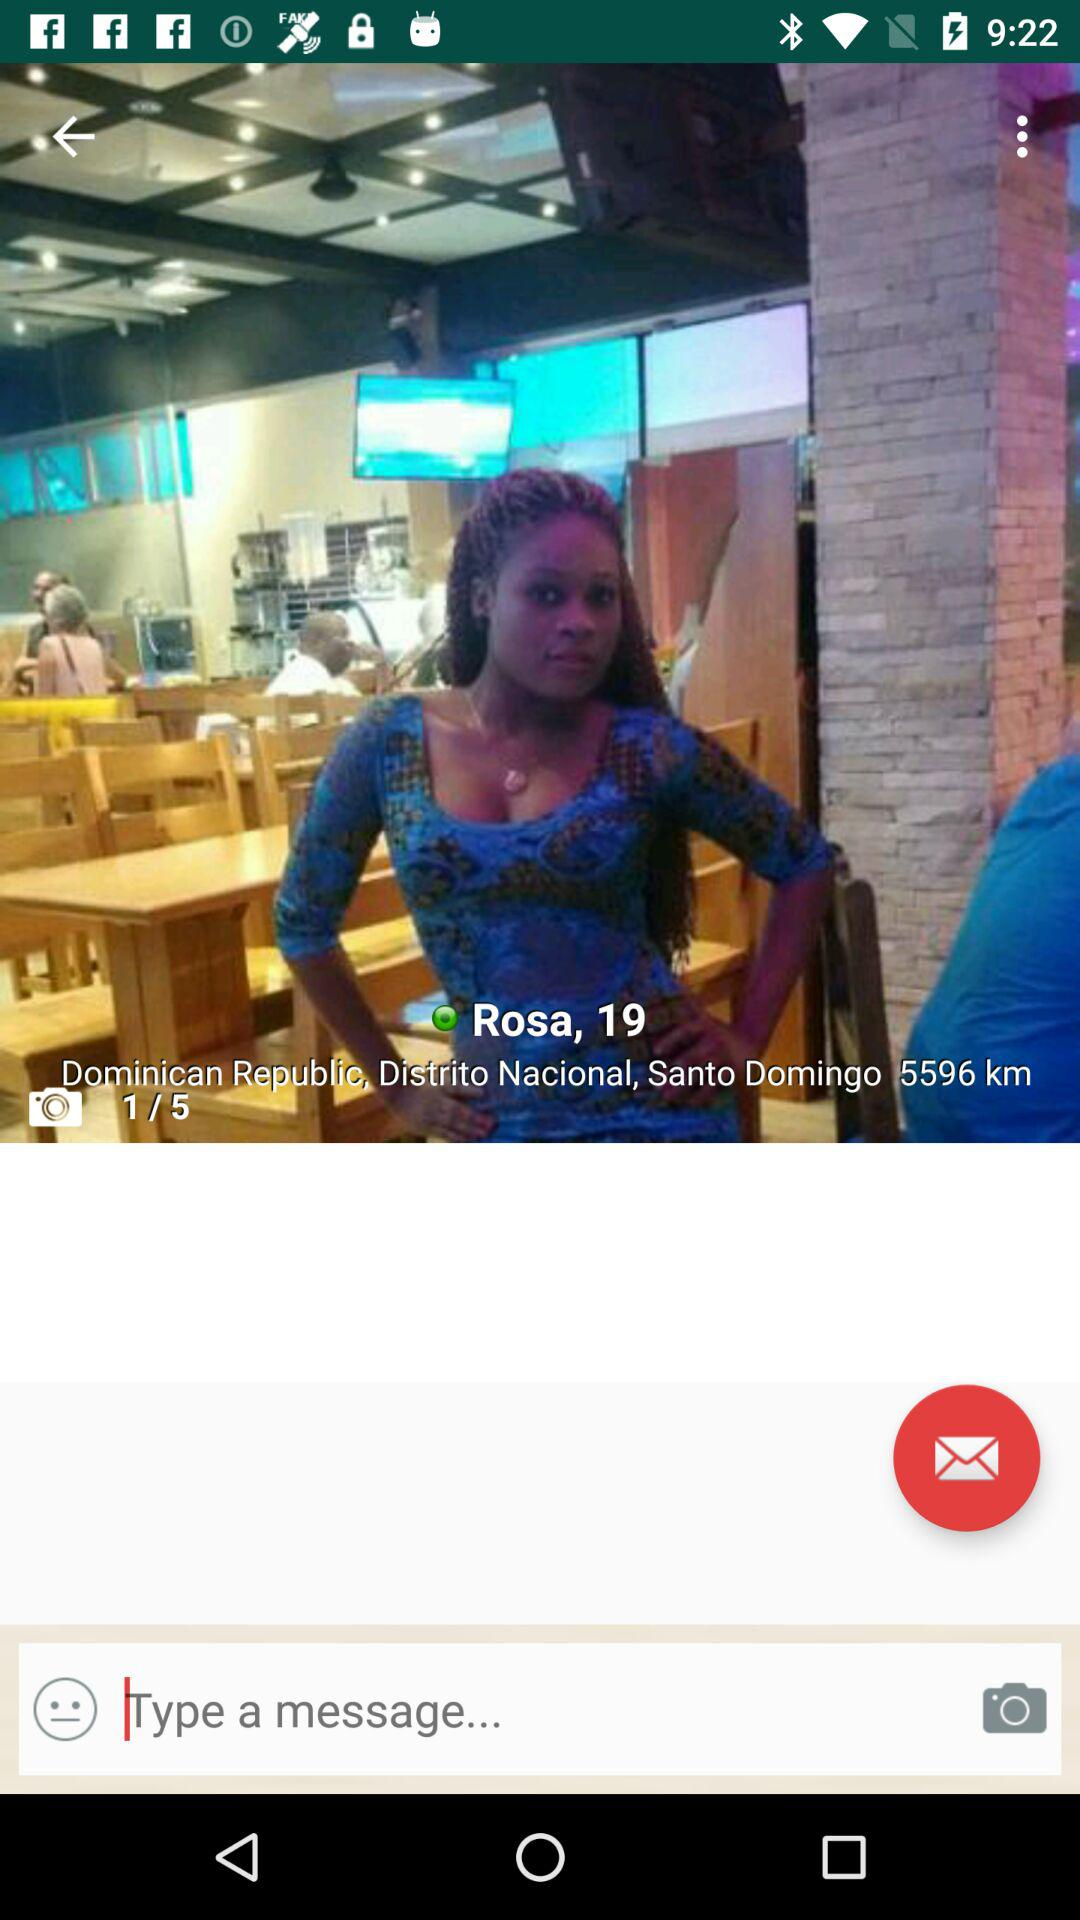How many total photos are there? There are a total of 5 photos. 